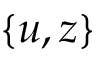<formula> <loc_0><loc_0><loc_500><loc_500>\{ u , z \}</formula> 